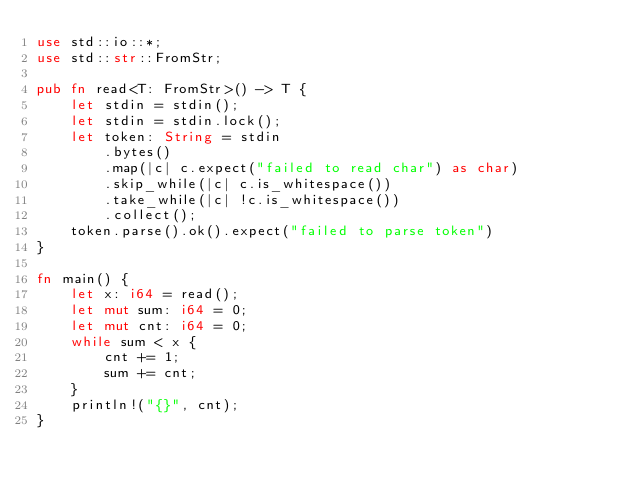<code> <loc_0><loc_0><loc_500><loc_500><_Rust_>use std::io::*;
use std::str::FromStr;

pub fn read<T: FromStr>() -> T {
    let stdin = stdin();
    let stdin = stdin.lock();
    let token: String = stdin
        .bytes()
        .map(|c| c.expect("failed to read char") as char)
        .skip_while(|c| c.is_whitespace())
        .take_while(|c| !c.is_whitespace())
        .collect();
    token.parse().ok().expect("failed to parse token")
}

fn main() {
    let x: i64 = read();
    let mut sum: i64 = 0;
    let mut cnt: i64 = 0;
    while sum < x {
        cnt += 1;
        sum += cnt;
    }
    println!("{}", cnt);
}
</code> 